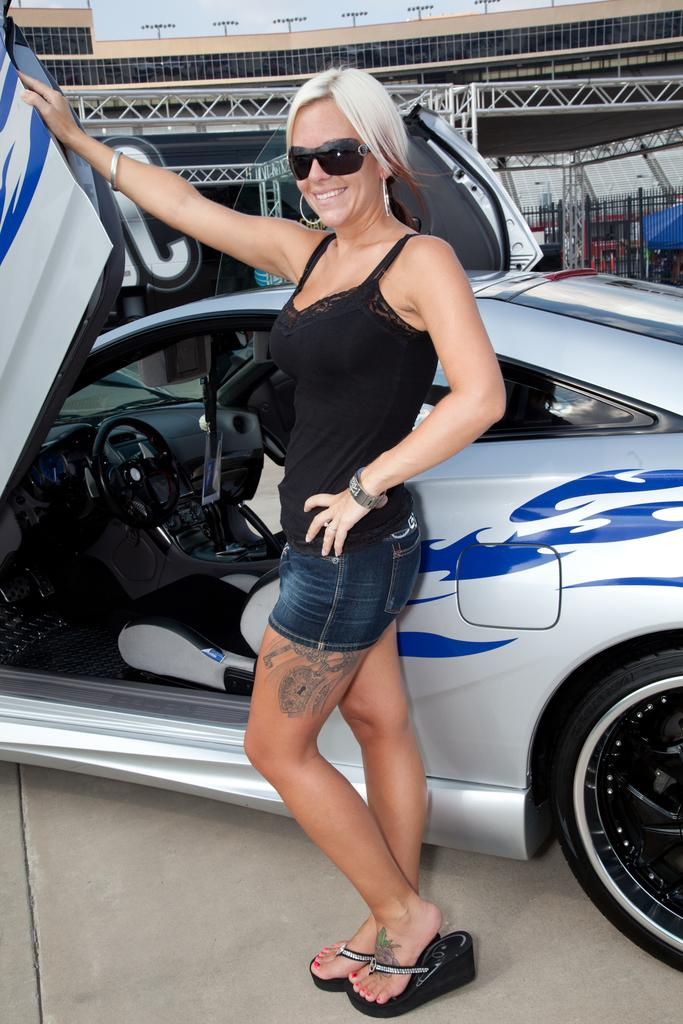What is the main subject in the foreground of the image? There is a woman standing near a car in the foreground. What can be seen in the background of the image? There is a stadium and lights visible in the background. What is the condition of the sky in the image? The sky is visible in the background. How many experts are present in the image? There is no mention of experts in the image, so it is not possible to determine their presence or number. 